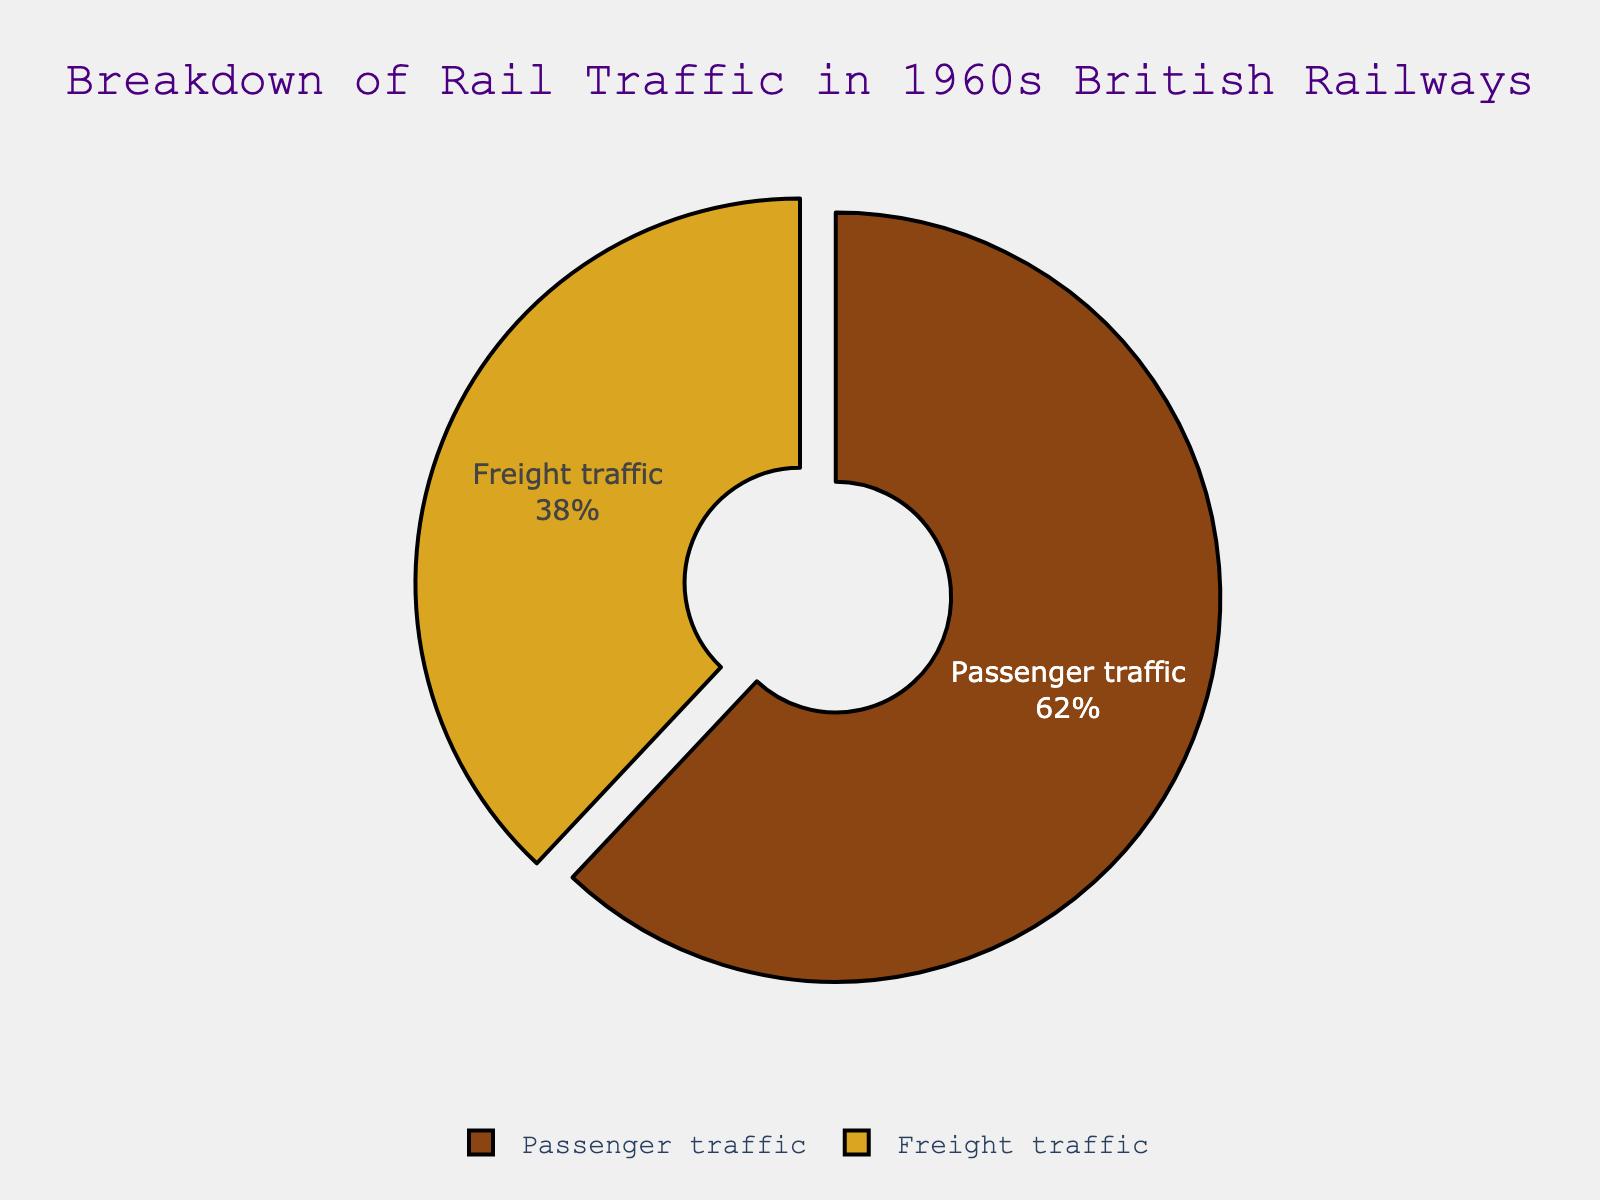What percentage of rail traffic in the 1960s was passenger traffic? The figure shows that passenger traffic constitutes 62% of the total rail traffic.
Answer: 62% What percentage of rail traffic in the 1960s was freight traffic? The figure indicates that freight traffic accounts for 38% of the total rail traffic.
Answer: 38% Which type of rail traffic had a larger percentage in the 1960s? By comparing the percentages, passenger traffic (62%) is larger than freight traffic (38%).
Answer: Passenger traffic What is the difference in percentage between passenger and freight traffic? The difference is calculated as 62% (passenger traffic) - 38% (freight traffic).
Answer: 24% If the total rail traffic is represented by 100 units, how many units represent freight traffic? Freight traffic is 38% of the total, so 38 units represent freight traffic.
Answer: 38 What fraction of the total rail traffic does the passenger traffic cover, and what fraction does the freight traffic cover? Passenger traffic covers 62/100, which simplifies to 31/50, and freight traffic covers 38/100, which simplifies to 19/50.
Answer: Passenger: 31/50, Freight: 19/50 What is the ratio of passenger traffic to freight traffic? The ratio is calculated by dividing the percentage of passenger traffic (62%) by the percentage of freight traffic (38%).
Answer: 62:38 or approximately 1.63:1 Based on the colors shown in the pie chart, which traffic type is represented by the brown color? Observing the visual attributes, the text within the brown segment indicates it represents freight traffic.
Answer: Freight traffic How much larger is the passenger traffic percentage compared to freight traffic? The passenger traffic percentage is larger by 24 points (62% - 38%).
Answer: 24 points What is the pull-out effect in the pie chart, and which segment does it highlight? The pull-out effect is a visual emphasis on one segment of the pie chart, highlighting the passenger traffic segment.
Answer: Passenger traffic 